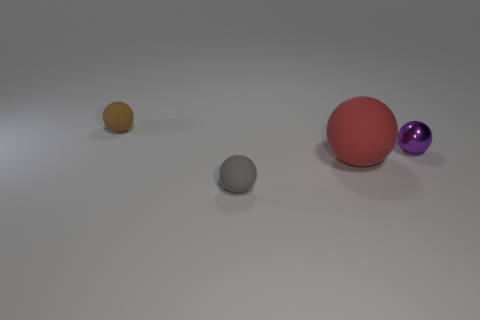There is a tiny matte object in front of the tiny sphere that is right of the tiny matte thing to the right of the tiny brown matte thing; what color is it?
Your answer should be compact. Gray. What is the material of the purple thing that is the same size as the gray ball?
Keep it short and to the point. Metal. What number of brown spheres have the same material as the tiny brown thing?
Keep it short and to the point. 0. Does the ball on the right side of the big object have the same size as the matte sphere that is in front of the large thing?
Ensure brevity in your answer.  Yes. What color is the tiny sphere on the right side of the large sphere?
Keep it short and to the point. Purple. There is a brown ball; is it the same size as the ball right of the red thing?
Provide a short and direct response. Yes. What is the size of the object left of the tiny object in front of the sphere that is right of the big red matte ball?
Ensure brevity in your answer.  Small. There is a brown matte sphere; what number of large red spheres are behind it?
Keep it short and to the point. 0. What material is the object on the left side of the small rubber thing that is right of the tiny brown rubber ball?
Your answer should be compact. Rubber. Is there anything else that is the same size as the gray rubber thing?
Your answer should be very brief. Yes. 